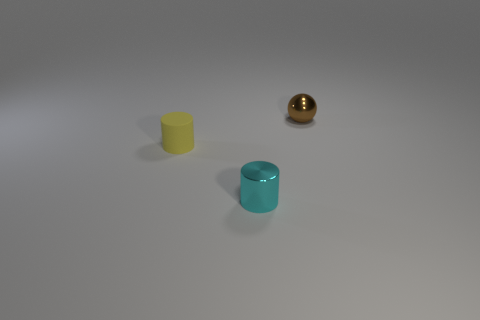Could you infer potential uses for the cylindrical objects? While the uses for the cylindrical objects are not explicitly indicated in the image, their shape and appearance could suggest they are containers or holders of some sort. The variation in color may also imply that they could be used for color-coding purposes, organizing items, or as decoration. Would the materials they are made of matter in their uses? Certainly, the materials of these objects would greatly affect their utility. If they are made of plastic, they could be lightweight storage for desk supplies or personal items. If they're ceramic or glass, they could serve as vases or decorative elements, and if they're metal, they could even be part of a machinery or serve as robust containers. 